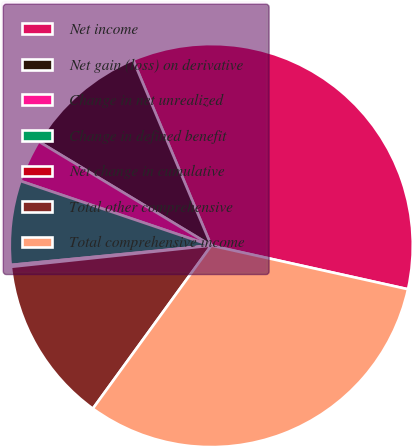Convert chart. <chart><loc_0><loc_0><loc_500><loc_500><pie_chart><fcel>Net income<fcel>Net gain (loss) on derivative<fcel>Change in net unrealized<fcel>Change in defined benefit<fcel>Net change in cumulative<fcel>Total other comprehensive<fcel>Total comprehensive income<nl><fcel>34.82%<fcel>10.02%<fcel>3.44%<fcel>6.73%<fcel>0.15%<fcel>13.32%<fcel>31.52%<nl></chart> 